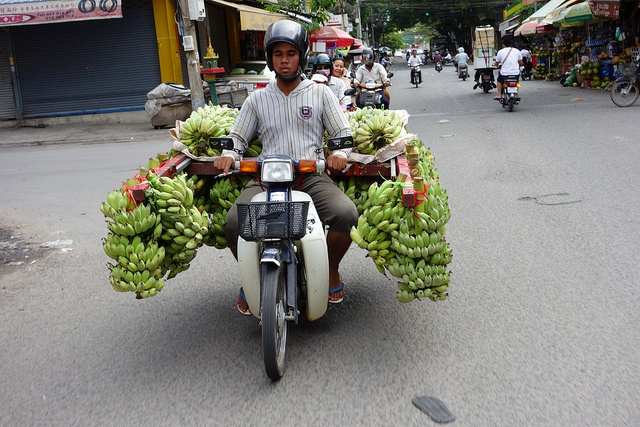Describe the objects in this image and their specific colors. I can see people in lightgray, black, darkgray, and gray tones, motorcycle in lightgray, black, gray, and darkgray tones, banana in lightgray, olive, and black tones, banana in lightgray, darkgreen, olive, and black tones, and banana in lightgray, black, darkgreen, olive, and khaki tones in this image. 